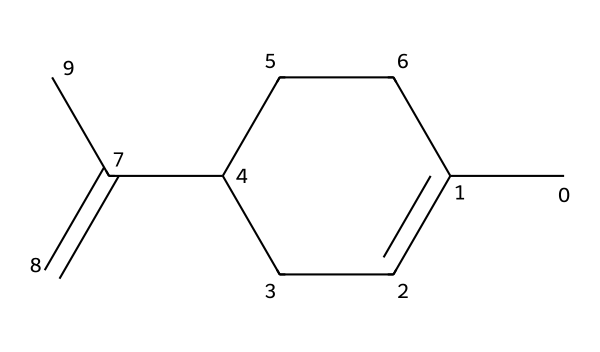How many carbon atoms are present in limonene? By examining the SMILES representation, each "C" corresponds to a carbon atom. Counting the number of carbon symbols, we find there are ten carbon atoms total.
Answer: ten What is the molecular formula for limonene? The molecular formula can be determined by counting the carbon (C), hydrogen (H), and any other present atoms in the SMILES. For limonene, it comprises ten carbons and sixteen hydrogens, resulting in the formula C10H16.
Answer: C10H16 Is limonene a saturated or unsaturated solvent? The presence of double bonds indicates that the molecule contains unsaturation. In the SMILES, the "=C" signifies a double bond, making limonene unsaturated.
Answer: unsaturated What functional group does limonene belong to? Limonene is categorized as a terpenoid, which can be identified as it is primarily composed of isoprene units (C5H8) and has a specific ring structure in its composition.
Answer: terpenoid How many double bonds are present in limonene? Observing the SMILES representation, there is one occurrence of a double bond indicated by the "=" sign in the structure, confirming the presence of one double bond.
Answer: one What type of solvent is limonene classified as? Limonene is primarily classified as a natural solvent due to its origin from citrus peels and its use in various eco-friendly applications, such as in cleaning agents and personal care products.
Answer: natural solvent 